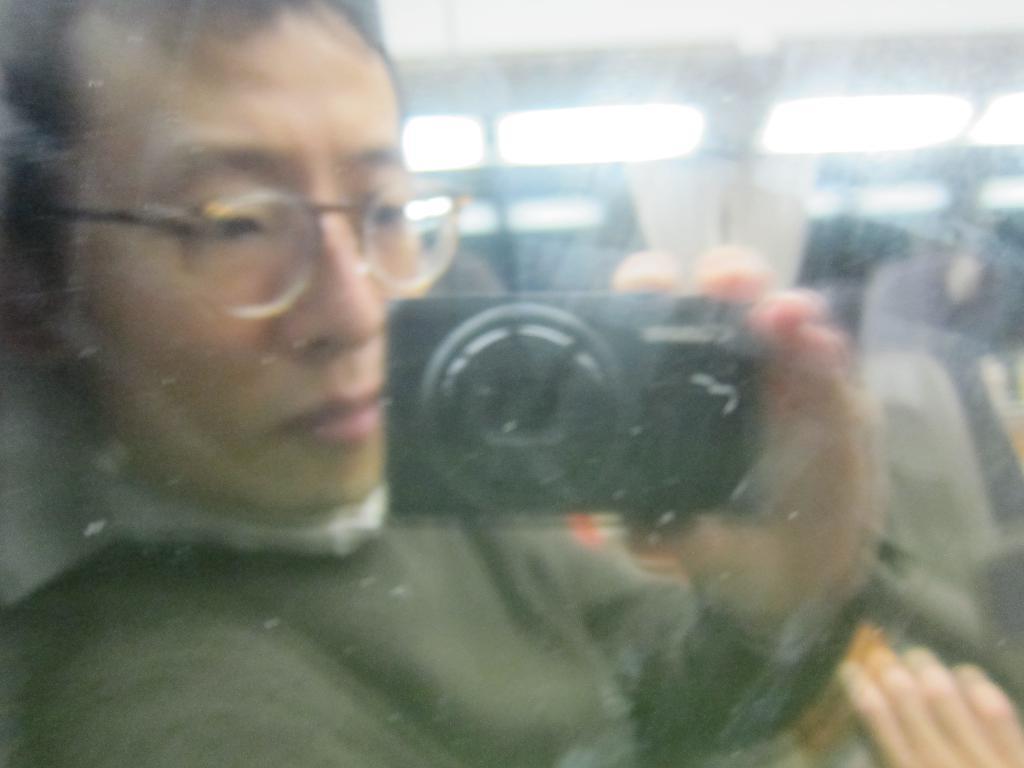How would you summarize this image in a sentence or two? This image is captured when the lady is sitting behind the glass holding camera. 